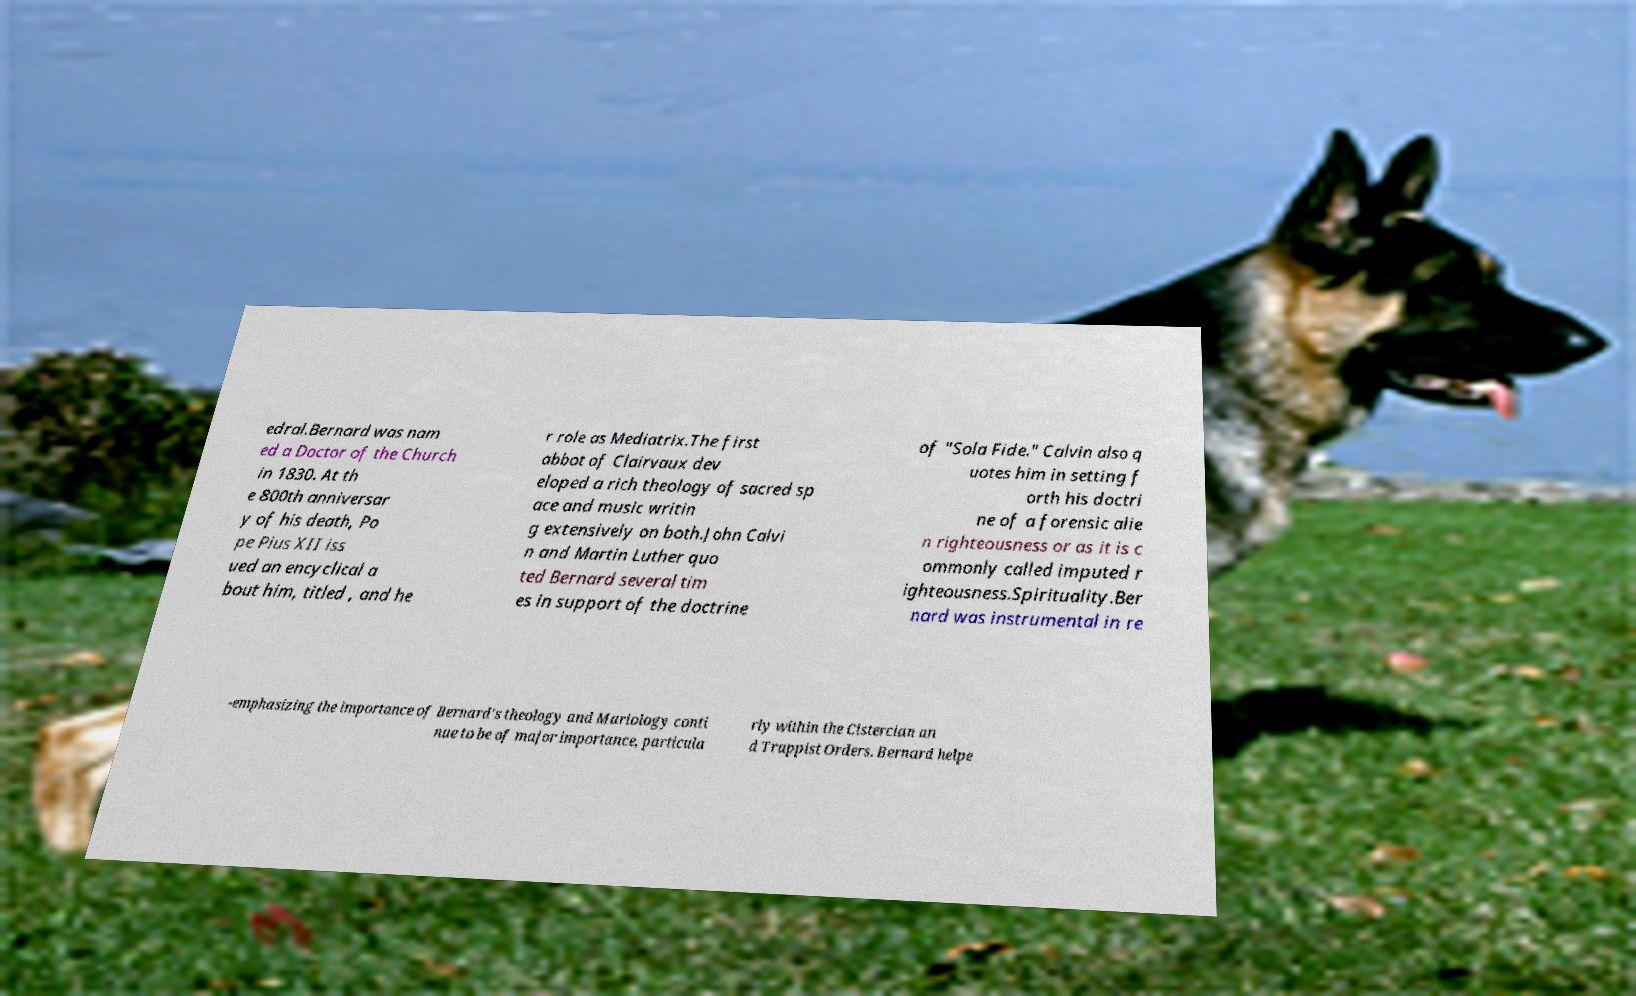What messages or text are displayed in this image? I need them in a readable, typed format. edral.Bernard was nam ed a Doctor of the Church in 1830. At th e 800th anniversar y of his death, Po pe Pius XII iss ued an encyclical a bout him, titled , and he r role as Mediatrix.The first abbot of Clairvaux dev eloped a rich theology of sacred sp ace and music writin g extensively on both.John Calvi n and Martin Luther quo ted Bernard several tim es in support of the doctrine of "Sola Fide." Calvin also q uotes him in setting f orth his doctri ne of a forensic alie n righteousness or as it is c ommonly called imputed r ighteousness.Spirituality.Ber nard was instrumental in re -emphasizing the importance of Bernard's theology and Mariology conti nue to be of major importance, particula rly within the Cistercian an d Trappist Orders. Bernard helpe 